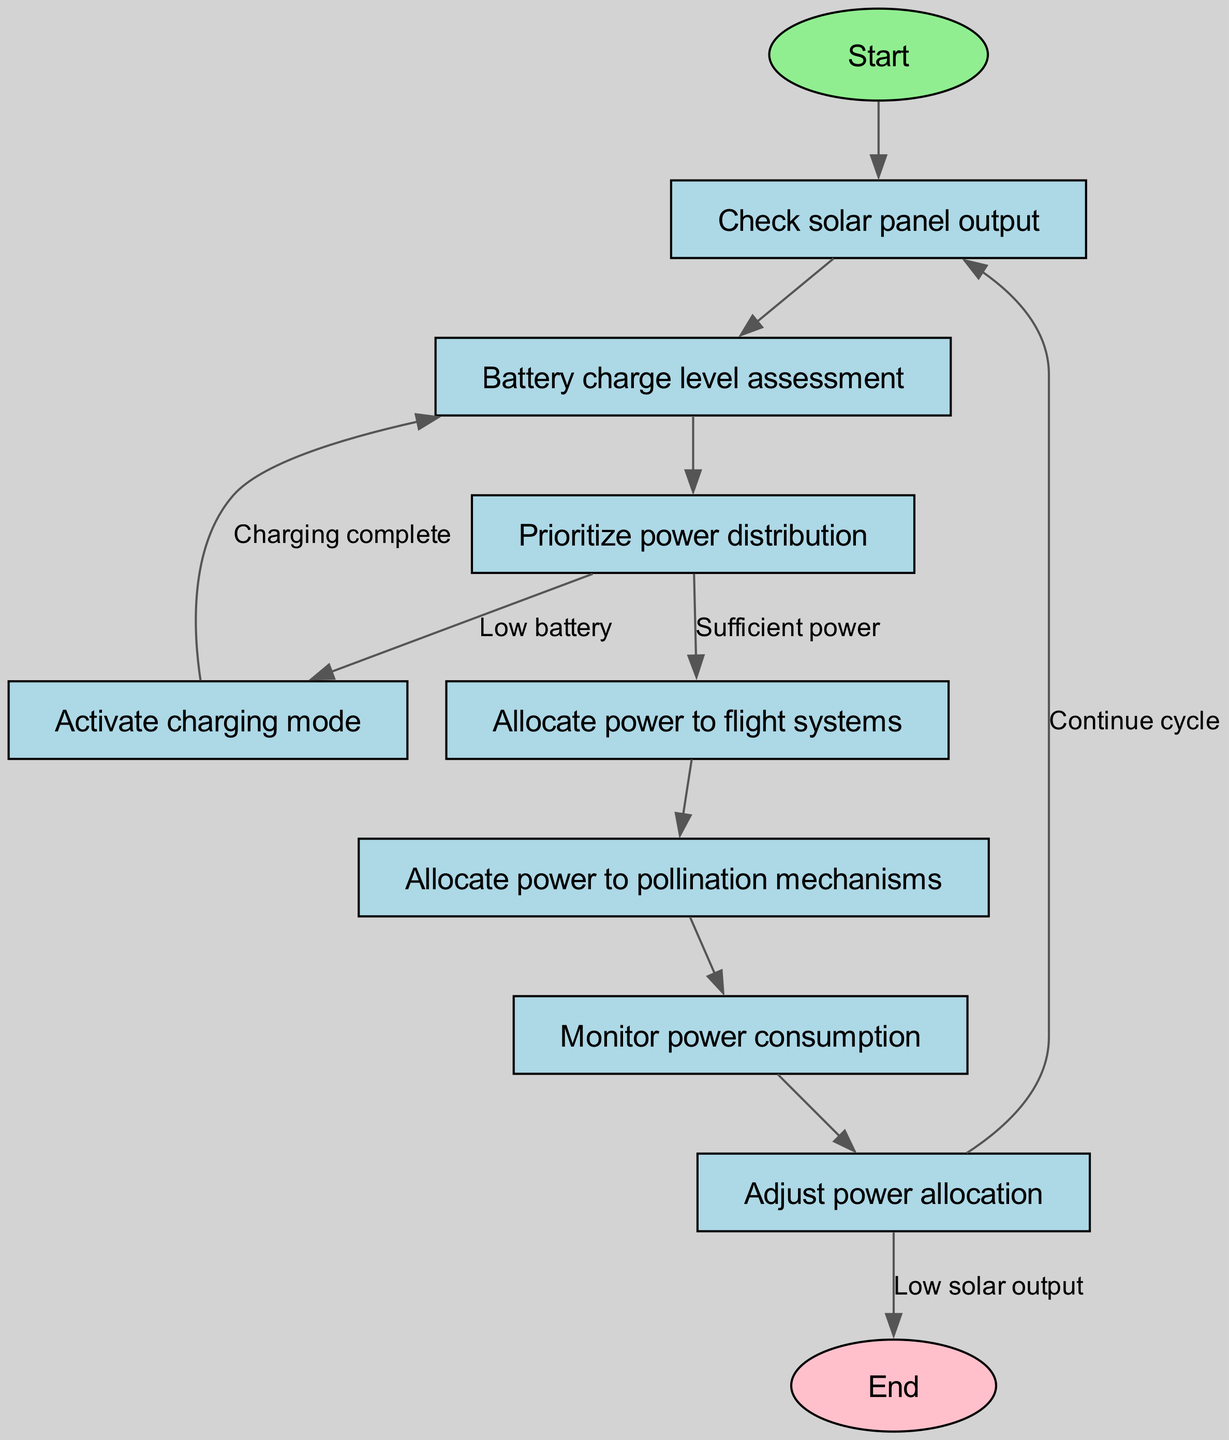What's the total number of nodes in the diagram? The diagram includes all nodes listed in the data section, specifically, these are: Start, Check solar panel output, Battery charge level assessment, Prioritize power distribution, Activate charging mode, Allocate power to flight systems, Allocate power to pollination mechanisms, Monitor power consumption, Adjust power allocation, and End. Counting these gives a total of 10 nodes.
Answer: 10 Which node follows "Check solar panel output"? The flow of the diagram indicates that after the "Check solar panel output" node, the next node is "Battery charge level assessment". This is a direct connection leading from output 2 to output 3 in the sequence.
Answer: Battery charge level assessment What decision occurs at "Prioritize power distribution"? At "Prioritize power distribution", the flow splits based on the battery's current state: it goes to "Activate charging mode" if the battery is low, or to "Allocate power to flight systems" if there is sufficient power. This node involves a critical decision based on battery assessment.
Answer: Low battery or Sufficient power What happens if power consumption is monitored? After monitoring power consumption in the "Monitor power consumption" node, the system proceeds to "Adjust power allocation". This indicates that there is an active response to the current power utilization.
Answer: Adjust power allocation What is the flow direction from "Allocate power to flight systems"? The flow direction from "Allocate power to flight systems" leads to "Allocate power to pollination mechanisms". This indicates that after power is allocated to flight systems, the next task is to allocate power to the mechanisms for pollination.
Answer: Allocate power to pollination mechanisms How many edges are connected to the "Start" node? The "Start" node is connected to one edge that leads to the "Check solar panel output" node, making the total number of edges linked to the "Start" node equal to 1.
Answer: 1 What indicates that the charging process is complete? The process indicates that charging is complete when the flow returns to the "Battery charge level assessment" node from "Activate charging mode". This shows that once charging is done, the system reassesses the battery level.
Answer: Charging complete Which node has a pink ellipsoidal shape? The "End" node is uniquely represented as an ellipsoid with a pink color, indicating completion of the flowchart's process. This is a distinctive feature that sets it apart from other nodes.
Answer: End 